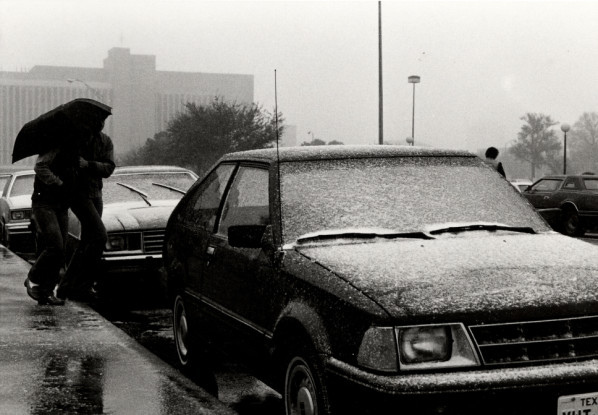<image>What is all of this sitting on the road? I don't know what all is sitting on the road. It might be snow or slush, and there might be cars as well. What is all of this sitting on the road? I am not sure what is all of this sitting on the road. It can be seen as snow or slush. 